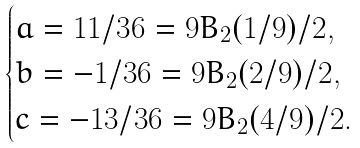<formula> <loc_0><loc_0><loc_500><loc_500>\begin{cases} a = 1 1 / 3 6 = 9 B _ { 2 } ( 1 / 9 ) / 2 , \\ b = - 1 / 3 6 = 9 B _ { 2 } ( 2 / 9 ) / 2 , \\ c = - 1 3 / 3 6 = 9 B _ { 2 } ( 4 / 9 ) / 2 . \end{cases}</formula> 